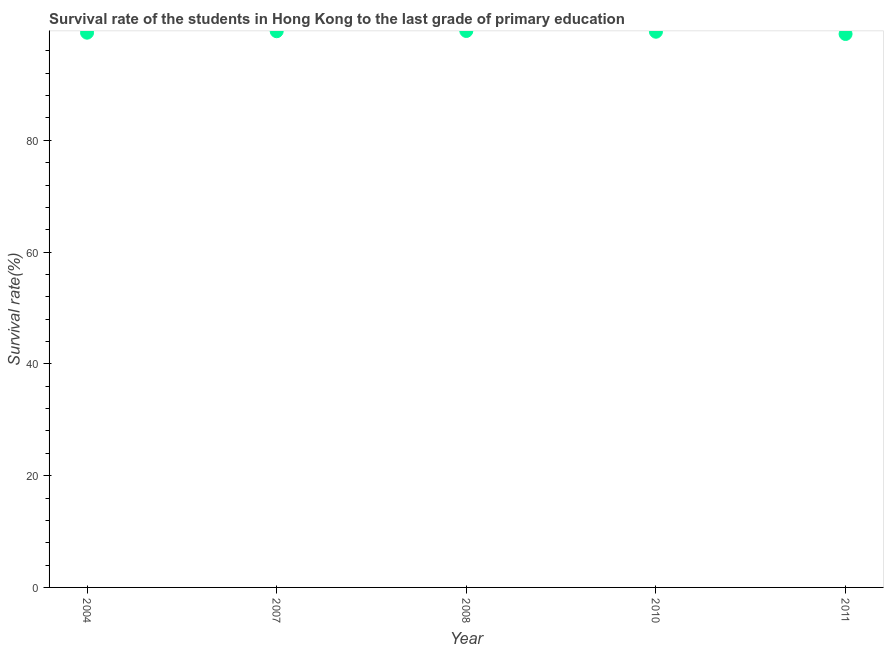What is the survival rate in primary education in 2008?
Make the answer very short. 99.56. Across all years, what is the maximum survival rate in primary education?
Your response must be concise. 99.56. Across all years, what is the minimum survival rate in primary education?
Your answer should be very brief. 99.02. In which year was the survival rate in primary education maximum?
Your response must be concise. 2008. In which year was the survival rate in primary education minimum?
Offer a terse response. 2011. What is the sum of the survival rate in primary education?
Provide a short and direct response. 496.78. What is the difference between the survival rate in primary education in 2004 and 2008?
Provide a succinct answer. -0.3. What is the average survival rate in primary education per year?
Offer a very short reply. 99.36. What is the median survival rate in primary education?
Your answer should be compact. 99.43. In how many years, is the survival rate in primary education greater than 4 %?
Ensure brevity in your answer.  5. What is the ratio of the survival rate in primary education in 2007 to that in 2011?
Provide a short and direct response. 1. Is the survival rate in primary education in 2007 less than that in 2011?
Provide a succinct answer. No. What is the difference between the highest and the second highest survival rate in primary education?
Your answer should be compact. 0.05. What is the difference between the highest and the lowest survival rate in primary education?
Ensure brevity in your answer.  0.54. In how many years, is the survival rate in primary education greater than the average survival rate in primary education taken over all years?
Your response must be concise. 3. Does the survival rate in primary education monotonically increase over the years?
Offer a terse response. No. How many dotlines are there?
Ensure brevity in your answer.  1. How many years are there in the graph?
Provide a succinct answer. 5. What is the title of the graph?
Offer a terse response. Survival rate of the students in Hong Kong to the last grade of primary education. What is the label or title of the Y-axis?
Give a very brief answer. Survival rate(%). What is the Survival rate(%) in 2004?
Give a very brief answer. 99.26. What is the Survival rate(%) in 2007?
Offer a terse response. 99.51. What is the Survival rate(%) in 2008?
Ensure brevity in your answer.  99.56. What is the Survival rate(%) in 2010?
Your response must be concise. 99.43. What is the Survival rate(%) in 2011?
Provide a short and direct response. 99.02. What is the difference between the Survival rate(%) in 2004 and 2007?
Provide a succinct answer. -0.26. What is the difference between the Survival rate(%) in 2004 and 2008?
Your response must be concise. -0.3. What is the difference between the Survival rate(%) in 2004 and 2010?
Your response must be concise. -0.17. What is the difference between the Survival rate(%) in 2004 and 2011?
Provide a succinct answer. 0.23. What is the difference between the Survival rate(%) in 2007 and 2008?
Offer a terse response. -0.05. What is the difference between the Survival rate(%) in 2007 and 2010?
Offer a very short reply. 0.09. What is the difference between the Survival rate(%) in 2007 and 2011?
Your answer should be very brief. 0.49. What is the difference between the Survival rate(%) in 2008 and 2010?
Your response must be concise. 0.14. What is the difference between the Survival rate(%) in 2008 and 2011?
Offer a very short reply. 0.54. What is the difference between the Survival rate(%) in 2010 and 2011?
Keep it short and to the point. 0.4. What is the ratio of the Survival rate(%) in 2004 to that in 2008?
Keep it short and to the point. 1. What is the ratio of the Survival rate(%) in 2004 to that in 2011?
Offer a very short reply. 1. What is the ratio of the Survival rate(%) in 2007 to that in 2010?
Provide a short and direct response. 1. What is the ratio of the Survival rate(%) in 2007 to that in 2011?
Offer a very short reply. 1. What is the ratio of the Survival rate(%) in 2008 to that in 2010?
Your answer should be compact. 1. What is the ratio of the Survival rate(%) in 2008 to that in 2011?
Provide a short and direct response. 1. What is the ratio of the Survival rate(%) in 2010 to that in 2011?
Your answer should be compact. 1. 